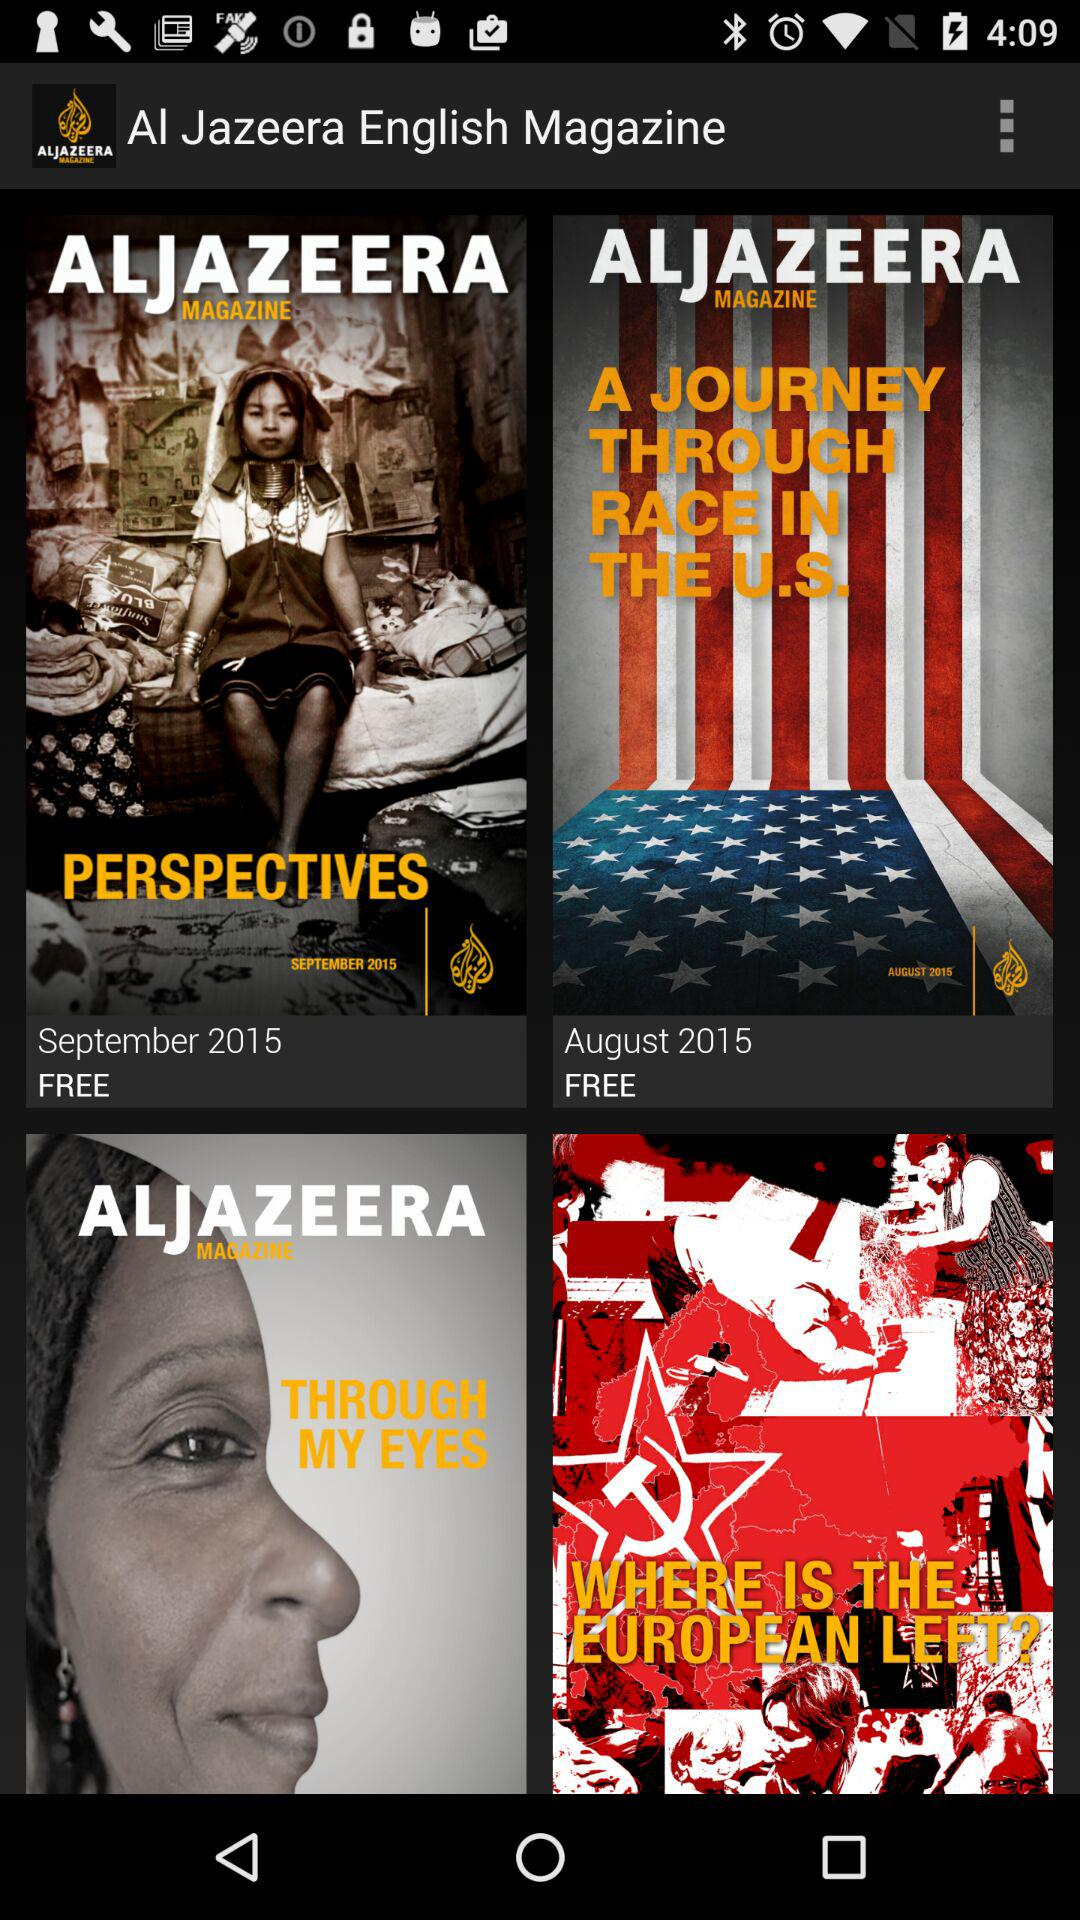What is the app title? The app title is "Al Jazeera English Magazine". 